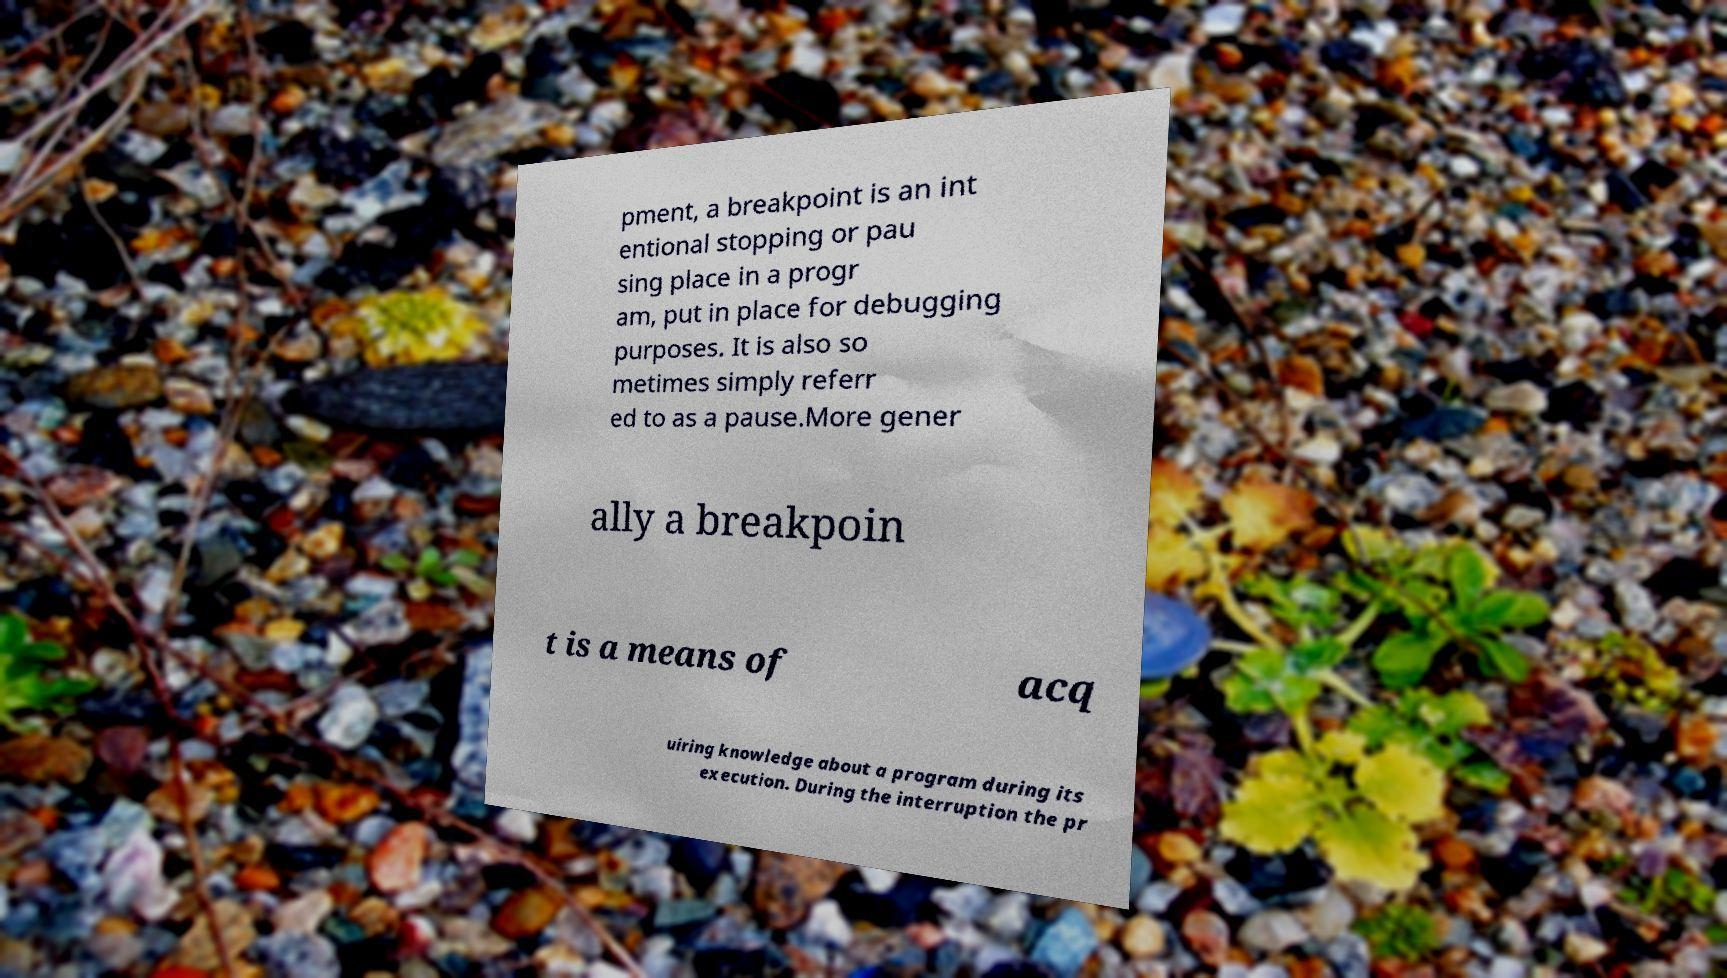Could you extract and type out the text from this image? pment, a breakpoint is an int entional stopping or pau sing place in a progr am, put in place for debugging purposes. It is also so metimes simply referr ed to as a pause.More gener ally a breakpoin t is a means of acq uiring knowledge about a program during its execution. During the interruption the pr 